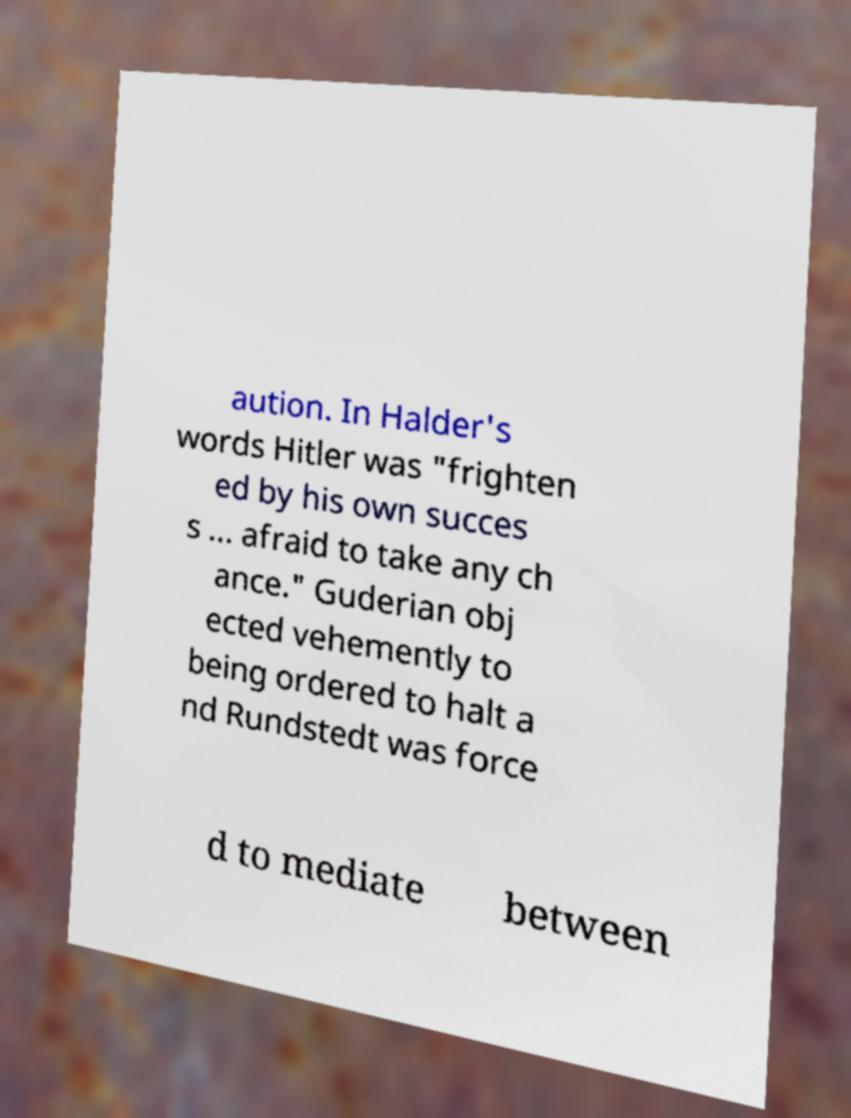Could you extract and type out the text from this image? aution. In Halder's words Hitler was "frighten ed by his own succes s ... afraid to take any ch ance." Guderian obj ected vehemently to being ordered to halt a nd Rundstedt was force d to mediate between 